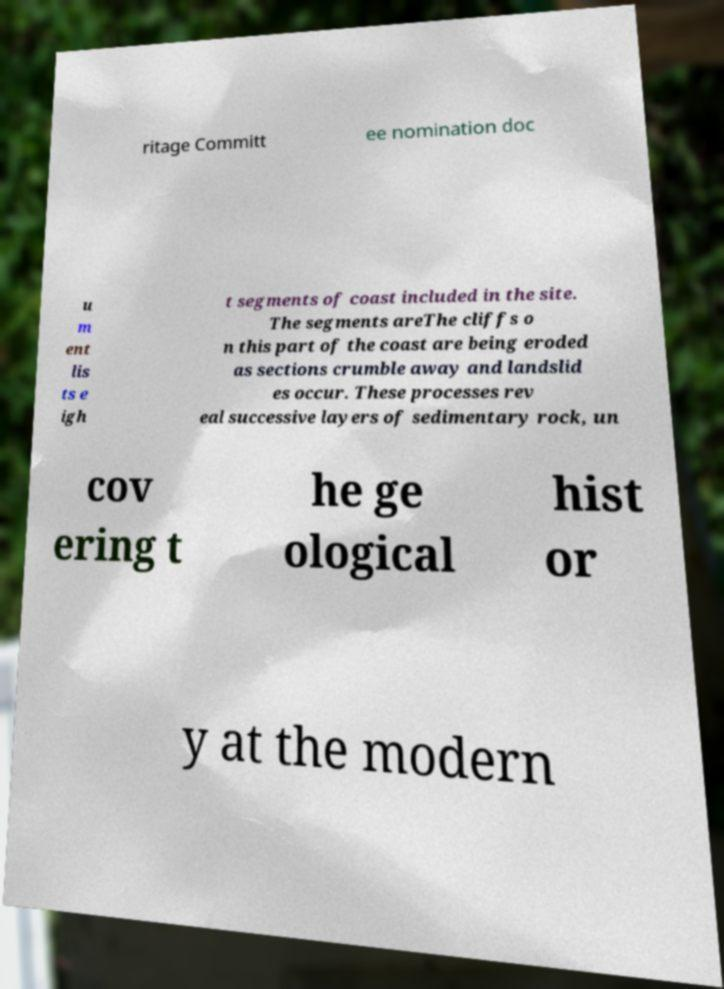I need the written content from this picture converted into text. Can you do that? ritage Committ ee nomination doc u m ent lis ts e igh t segments of coast included in the site. The segments areThe cliffs o n this part of the coast are being eroded as sections crumble away and landslid es occur. These processes rev eal successive layers of sedimentary rock, un cov ering t he ge ological hist or y at the modern 